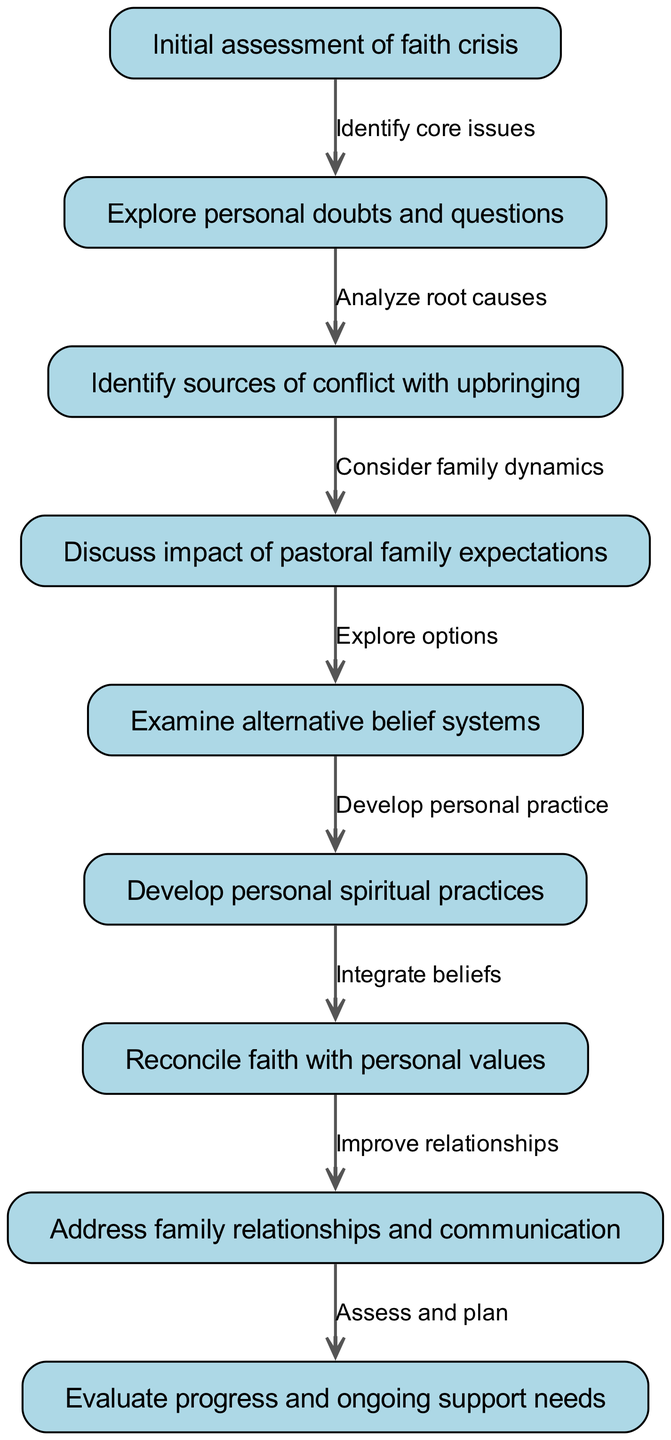What is the first step in the clinical pathway? The first step in the clinical pathway is indicated by the node labeled "Initial assessment of faith crisis". This node is placed at the beginning of the flowchart, representing the starting point of the counseling process.
Answer: Initial assessment of faith crisis How many nodes are there in total in the diagram? By counting the nodes listed under the "nodes" section in the data, there are nine distinct steps present in the clinical pathway.
Answer: 9 What is the arrow text between the first and second node? The arrow connecting the first node ("Initial assessment of faith crisis") to the second node ("Explore personal doubts and questions") contains the text "Identify core issues", specifying the relationship between these two steps.
Answer: Identify core issues Which step discusses family relationships? The step that addresses family relationships is represented by the node labeled "Address family relationships and communication", which is positioned before the final evaluation step.
Answer: Address family relationships and communication What is the last node in the pathway? The final node in the clinical pathway is titled "Evaluate progress and ongoing support needs", marking the completion of the journey taken through the counseling process.
Answer: Evaluate progress and ongoing support needs Which node explores alternative belief systems? The node that focuses on examining alternative belief systems is labeled "Examine alternative belief systems", and it follows the discussion on family expectations in the pathway.
Answer: Examine alternative belief systems What is the relationship between the nodes "Develop personal spiritual practices" and "Reconcile faith with personal values"? The flow between these two nodes states "Integrate beliefs", illustrating that the development of personal spiritual practices leads into the reconciliation of faith with individual values and beliefs.
Answer: Integrate beliefs In which step is the impact of pastoral family expectations discussed? The step that discusses the impact of pastoral family expectations is noted as "Discuss impact of pastoral family expectations", which follows the identification of sources of conflict in faith.
Answer: Discuss impact of pastoral family expectations How does the pathway evaluate progress? The pathway evaluates progress in the last node, "Evaluate progress and ongoing support needs", where assessment and planning for further support take place.
Answer: Evaluate progress and ongoing support needs 